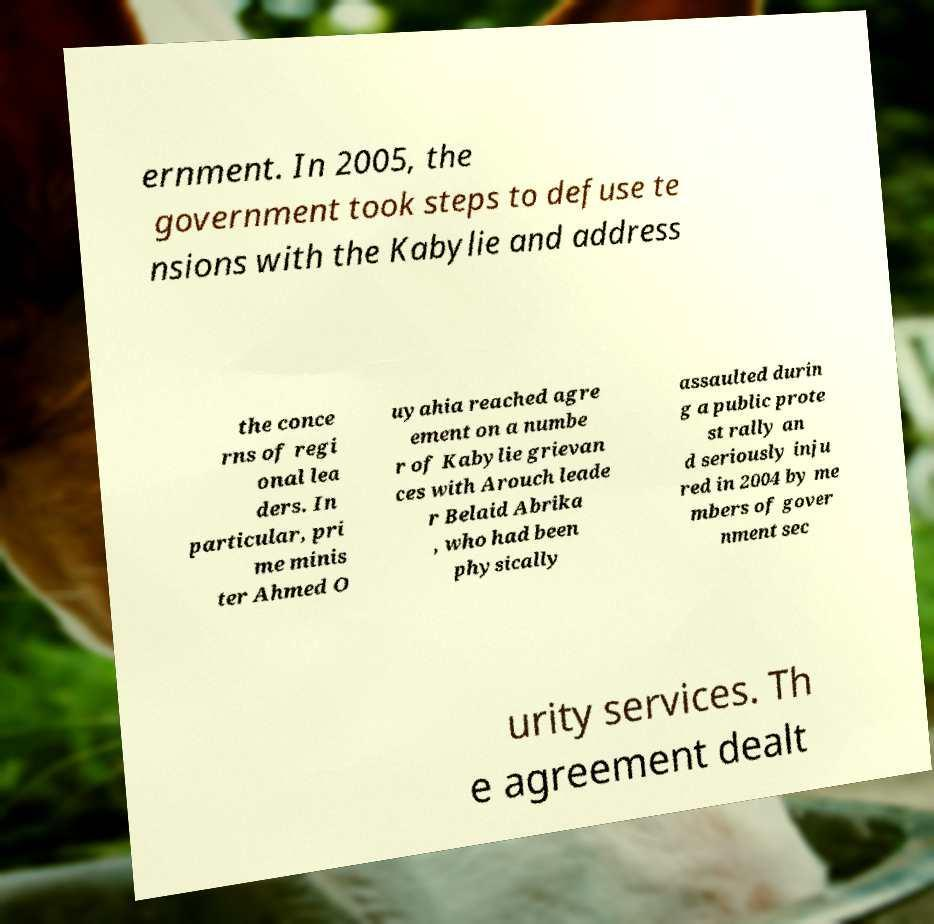There's text embedded in this image that I need extracted. Can you transcribe it verbatim? ernment. In 2005, the government took steps to defuse te nsions with the Kabylie and address the conce rns of regi onal lea ders. In particular, pri me minis ter Ahmed O uyahia reached agre ement on a numbe r of Kabylie grievan ces with Arouch leade r Belaid Abrika , who had been physically assaulted durin g a public prote st rally an d seriously inju red in 2004 by me mbers of gover nment sec urity services. Th e agreement dealt 